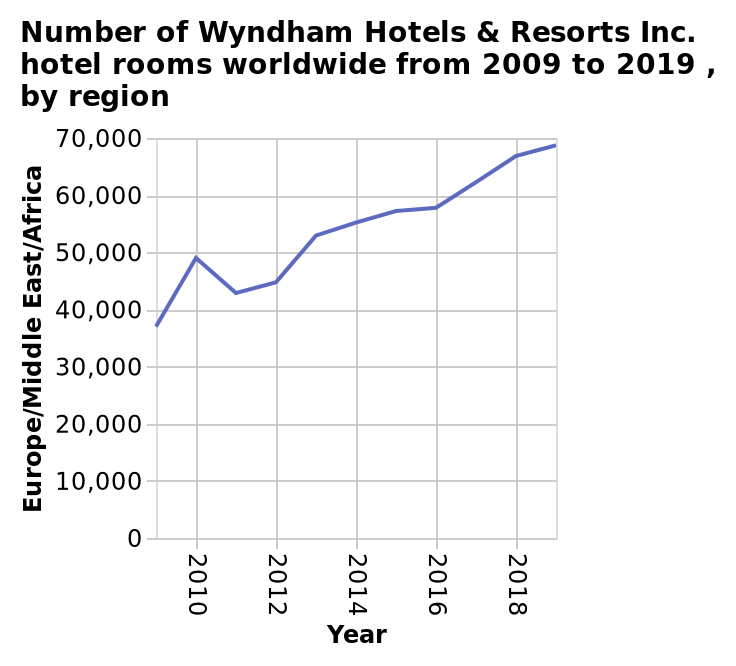<image>
Offer a thorough analysis of the image. Wyndham hotels and resorts have witnessed a steep rise  in the number of hotel rooms in Europe/Middle East/Africa 2009 to 2019 with an approximate increase of 30000 rooms. Which region has experienced the increase in hotel rooms for Wyndham hotels and resorts from 2009 to 2019? The increase in hotel rooms for Wyndham hotels and resorts took place in Europe/Middle East/Africa from 2009 to 2019. How many rooms approximately have been added by Wyndham hotels and resorts in Europe/Middle East/Africa from 2009 to 2019?  Approximately 30,000 rooms have been added by Wyndham hotels and resorts in Europe/Middle East/Africa from 2009 to 2019. What is the highest number of Wyndham Hotels & Resorts Inc. hotel rooms in Europe/Middle East/Africa shown on the line chart? The highest number of Wyndham Hotels & Resorts Inc. hotel rooms in Europe/Middle East/Africa shown on the line chart is 70,000. 